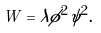<formula> <loc_0><loc_0><loc_500><loc_500>W = \lambda \phi ^ { 2 } \psi ^ { 2 } .</formula> 